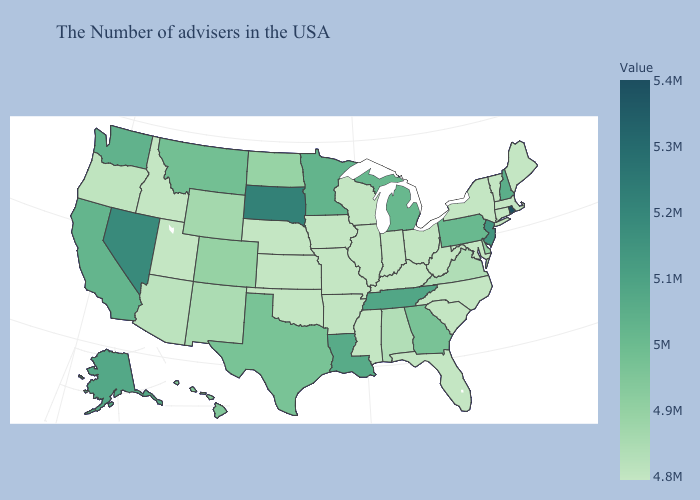Among the states that border New Mexico , which have the lowest value?
Quick response, please. Oklahoma, Utah. Does Alabama have the highest value in the South?
Answer briefly. No. Which states hav the highest value in the MidWest?
Keep it brief. South Dakota. Among the states that border Texas , which have the lowest value?
Short answer required. Oklahoma. Which states have the lowest value in the MidWest?
Quick response, please. Ohio, Indiana, Wisconsin, Illinois, Missouri, Iowa, Kansas, Nebraska. Which states hav the highest value in the MidWest?
Answer briefly. South Dakota. 